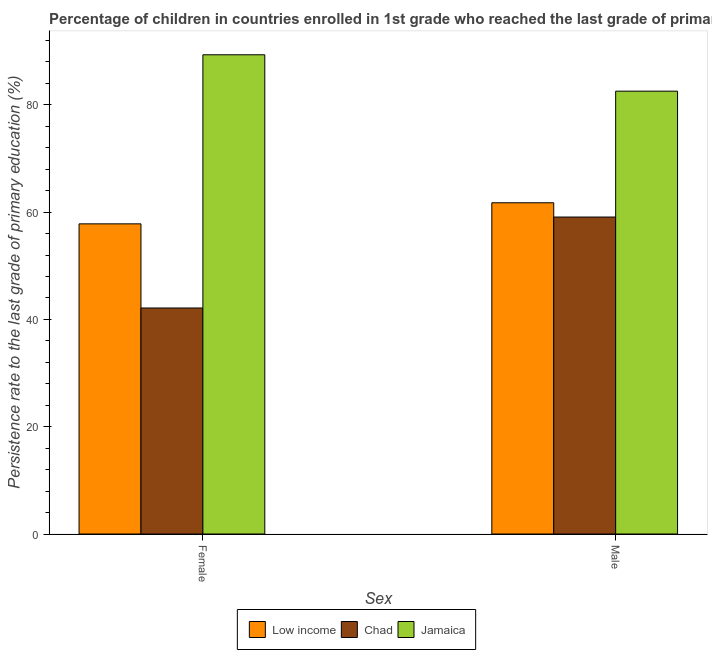Are the number of bars on each tick of the X-axis equal?
Offer a very short reply. Yes. How many bars are there on the 2nd tick from the left?
Keep it short and to the point. 3. What is the label of the 2nd group of bars from the left?
Your response must be concise. Male. What is the persistence rate of male students in Chad?
Give a very brief answer. 59.08. Across all countries, what is the maximum persistence rate of male students?
Your response must be concise. 82.54. Across all countries, what is the minimum persistence rate of male students?
Ensure brevity in your answer.  59.08. In which country was the persistence rate of female students maximum?
Provide a short and direct response. Jamaica. In which country was the persistence rate of female students minimum?
Provide a succinct answer. Chad. What is the total persistence rate of male students in the graph?
Keep it short and to the point. 203.37. What is the difference between the persistence rate of male students in Low income and that in Chad?
Your answer should be compact. 2.66. What is the difference between the persistence rate of female students in Chad and the persistence rate of male students in Jamaica?
Provide a short and direct response. -40.42. What is the average persistence rate of male students per country?
Your response must be concise. 67.79. What is the difference between the persistence rate of female students and persistence rate of male students in Low income?
Offer a terse response. -3.93. What is the ratio of the persistence rate of female students in Jamaica to that in Low income?
Provide a short and direct response. 1.55. In how many countries, is the persistence rate of male students greater than the average persistence rate of male students taken over all countries?
Your response must be concise. 1. What does the 3rd bar from the left in Female represents?
Ensure brevity in your answer.  Jamaica. What does the 3rd bar from the right in Male represents?
Your answer should be compact. Low income. Does the graph contain grids?
Provide a succinct answer. No. Where does the legend appear in the graph?
Give a very brief answer. Bottom center. How are the legend labels stacked?
Provide a succinct answer. Horizontal. What is the title of the graph?
Keep it short and to the point. Percentage of children in countries enrolled in 1st grade who reached the last grade of primary education. What is the label or title of the X-axis?
Provide a short and direct response. Sex. What is the label or title of the Y-axis?
Offer a terse response. Persistence rate to the last grade of primary education (%). What is the Persistence rate to the last grade of primary education (%) of Low income in Female?
Make the answer very short. 57.81. What is the Persistence rate to the last grade of primary education (%) of Chad in Female?
Offer a terse response. 42.13. What is the Persistence rate to the last grade of primary education (%) of Jamaica in Female?
Provide a short and direct response. 89.33. What is the Persistence rate to the last grade of primary education (%) of Low income in Male?
Make the answer very short. 61.74. What is the Persistence rate to the last grade of primary education (%) of Chad in Male?
Your response must be concise. 59.08. What is the Persistence rate to the last grade of primary education (%) of Jamaica in Male?
Keep it short and to the point. 82.54. Across all Sex, what is the maximum Persistence rate to the last grade of primary education (%) in Low income?
Offer a terse response. 61.74. Across all Sex, what is the maximum Persistence rate to the last grade of primary education (%) in Chad?
Your answer should be compact. 59.08. Across all Sex, what is the maximum Persistence rate to the last grade of primary education (%) in Jamaica?
Offer a terse response. 89.33. Across all Sex, what is the minimum Persistence rate to the last grade of primary education (%) in Low income?
Offer a terse response. 57.81. Across all Sex, what is the minimum Persistence rate to the last grade of primary education (%) of Chad?
Your response must be concise. 42.13. Across all Sex, what is the minimum Persistence rate to the last grade of primary education (%) of Jamaica?
Keep it short and to the point. 82.54. What is the total Persistence rate to the last grade of primary education (%) in Low income in the graph?
Your answer should be compact. 119.55. What is the total Persistence rate to the last grade of primary education (%) in Chad in the graph?
Keep it short and to the point. 101.21. What is the total Persistence rate to the last grade of primary education (%) in Jamaica in the graph?
Your response must be concise. 171.87. What is the difference between the Persistence rate to the last grade of primary education (%) in Low income in Female and that in Male?
Give a very brief answer. -3.93. What is the difference between the Persistence rate to the last grade of primary education (%) in Chad in Female and that in Male?
Your answer should be compact. -16.95. What is the difference between the Persistence rate to the last grade of primary education (%) in Jamaica in Female and that in Male?
Offer a very short reply. 6.78. What is the difference between the Persistence rate to the last grade of primary education (%) in Low income in Female and the Persistence rate to the last grade of primary education (%) in Chad in Male?
Your response must be concise. -1.27. What is the difference between the Persistence rate to the last grade of primary education (%) in Low income in Female and the Persistence rate to the last grade of primary education (%) in Jamaica in Male?
Make the answer very short. -24.73. What is the difference between the Persistence rate to the last grade of primary education (%) of Chad in Female and the Persistence rate to the last grade of primary education (%) of Jamaica in Male?
Make the answer very short. -40.42. What is the average Persistence rate to the last grade of primary education (%) in Low income per Sex?
Offer a very short reply. 59.78. What is the average Persistence rate to the last grade of primary education (%) of Chad per Sex?
Make the answer very short. 50.61. What is the average Persistence rate to the last grade of primary education (%) of Jamaica per Sex?
Keep it short and to the point. 85.94. What is the difference between the Persistence rate to the last grade of primary education (%) in Low income and Persistence rate to the last grade of primary education (%) in Chad in Female?
Your response must be concise. 15.68. What is the difference between the Persistence rate to the last grade of primary education (%) of Low income and Persistence rate to the last grade of primary education (%) of Jamaica in Female?
Your response must be concise. -31.52. What is the difference between the Persistence rate to the last grade of primary education (%) of Chad and Persistence rate to the last grade of primary education (%) of Jamaica in Female?
Keep it short and to the point. -47.2. What is the difference between the Persistence rate to the last grade of primary education (%) of Low income and Persistence rate to the last grade of primary education (%) of Chad in Male?
Your answer should be compact. 2.66. What is the difference between the Persistence rate to the last grade of primary education (%) of Low income and Persistence rate to the last grade of primary education (%) of Jamaica in Male?
Provide a succinct answer. -20.8. What is the difference between the Persistence rate to the last grade of primary education (%) in Chad and Persistence rate to the last grade of primary education (%) in Jamaica in Male?
Provide a short and direct response. -23.46. What is the ratio of the Persistence rate to the last grade of primary education (%) in Low income in Female to that in Male?
Ensure brevity in your answer.  0.94. What is the ratio of the Persistence rate to the last grade of primary education (%) of Chad in Female to that in Male?
Give a very brief answer. 0.71. What is the ratio of the Persistence rate to the last grade of primary education (%) of Jamaica in Female to that in Male?
Provide a succinct answer. 1.08. What is the difference between the highest and the second highest Persistence rate to the last grade of primary education (%) in Low income?
Offer a very short reply. 3.93. What is the difference between the highest and the second highest Persistence rate to the last grade of primary education (%) in Chad?
Your answer should be compact. 16.95. What is the difference between the highest and the second highest Persistence rate to the last grade of primary education (%) in Jamaica?
Provide a succinct answer. 6.78. What is the difference between the highest and the lowest Persistence rate to the last grade of primary education (%) of Low income?
Offer a very short reply. 3.93. What is the difference between the highest and the lowest Persistence rate to the last grade of primary education (%) in Chad?
Your answer should be compact. 16.95. What is the difference between the highest and the lowest Persistence rate to the last grade of primary education (%) of Jamaica?
Give a very brief answer. 6.78. 